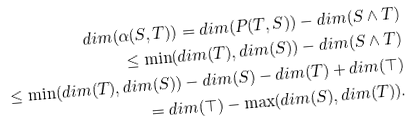<formula> <loc_0><loc_0><loc_500><loc_500>d i m ( \alpha ( S , T ) ) = d i m ( P ( T , S ) ) - d i m ( S \land T ) \\ \leq \min ( d i m ( T ) , d i m ( S ) ) - d i m ( S \land T ) \\ \leq \min ( d i m ( T ) , d i m ( S ) ) - d i m ( S ) - d i m ( T ) + d i m ( \top ) \\ = d i m ( \top ) - \max ( d i m ( S ) , d i m ( T ) ) .</formula> 